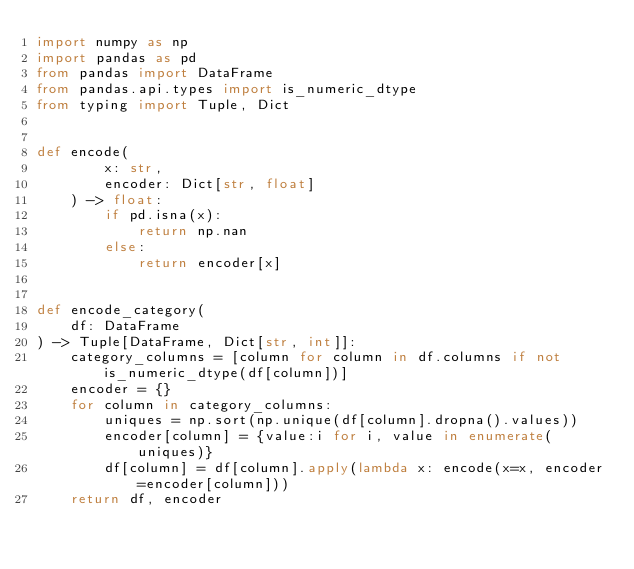Convert code to text. <code><loc_0><loc_0><loc_500><loc_500><_Python_>import numpy as np
import pandas as pd
from pandas import DataFrame
from pandas.api.types import is_numeric_dtype
from typing import Tuple, Dict


def encode(
        x: str,
        encoder: Dict[str, float]
    ) -> float:
        if pd.isna(x):
            return np.nan
        else:
            return encoder[x]


def encode_category(
    df: DataFrame
) -> Tuple[DataFrame, Dict[str, int]]:
    category_columns = [column for column in df.columns if not is_numeric_dtype(df[column])]
    encoder = {}
    for column in category_columns:
        uniques = np.sort(np.unique(df[column].dropna().values))
        encoder[column] = {value:i for i, value in enumerate(uniques)}
        df[column] = df[column].apply(lambda x: encode(x=x, encoder=encoder[column]))
    return df, encoder
</code> 